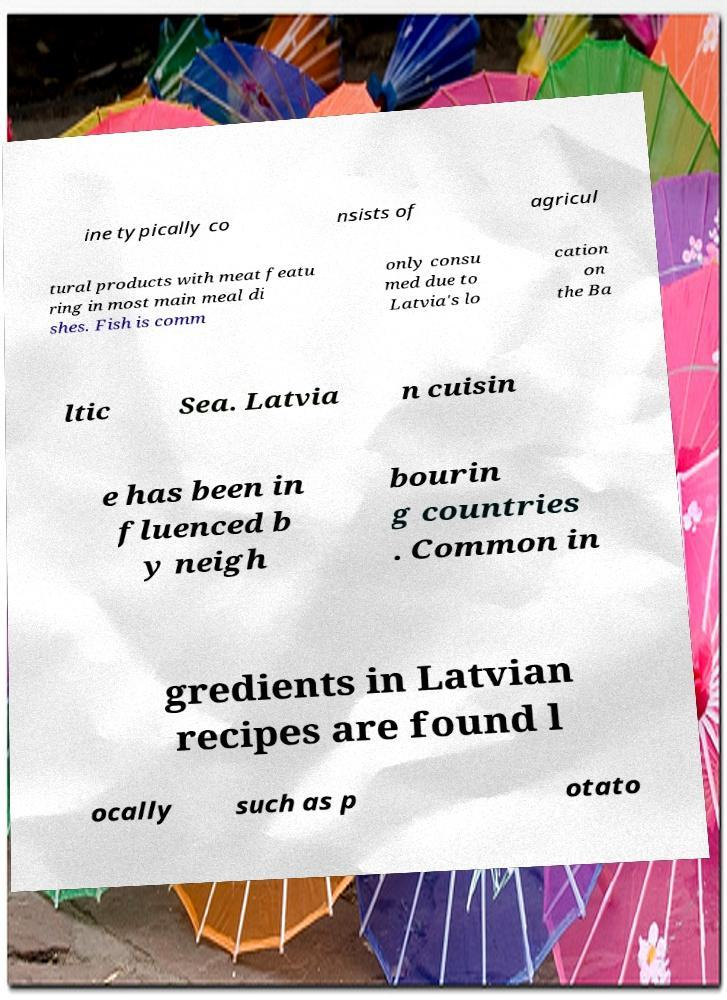Can you accurately transcribe the text from the provided image for me? ine typically co nsists of agricul tural products with meat featu ring in most main meal di shes. Fish is comm only consu med due to Latvia's lo cation on the Ba ltic Sea. Latvia n cuisin e has been in fluenced b y neigh bourin g countries . Common in gredients in Latvian recipes are found l ocally such as p otato 